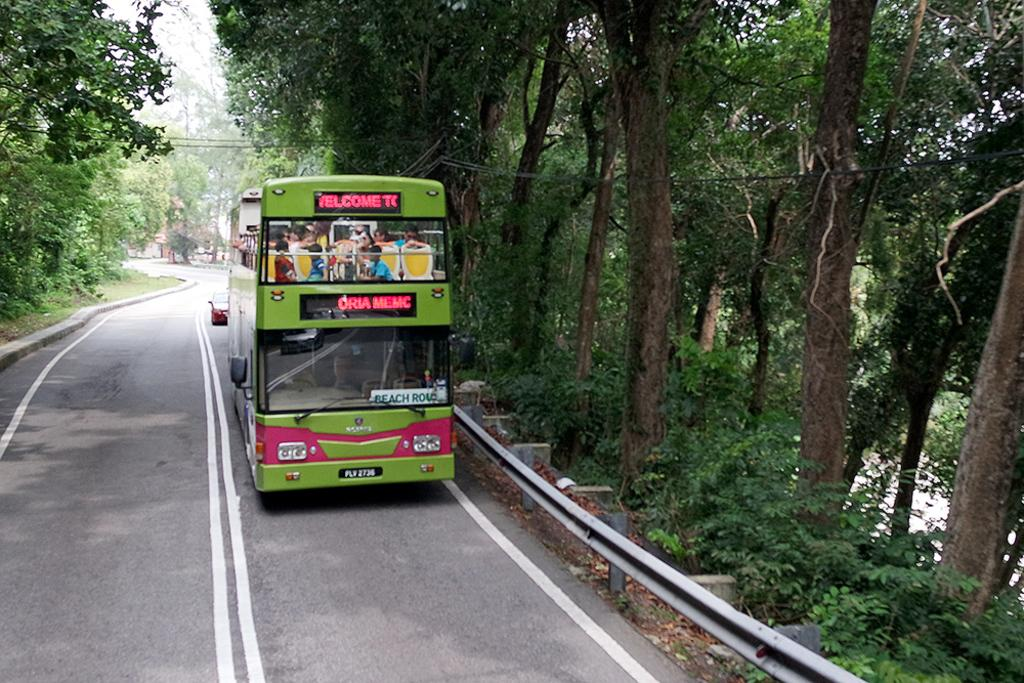What is the main subject in the center of the image? There is a bus in the center of the image. What other vehicle can be seen in the image? There is a car on the road in the image. What can be seen in the background of the image? There are trees and sky visible in the background of the image. What else is present in the image? There are wires in the image. What type of reaction can be seen from the team in the image? There is no team or reaction present in the image; it features a bus, a car, trees, sky, and wires. 